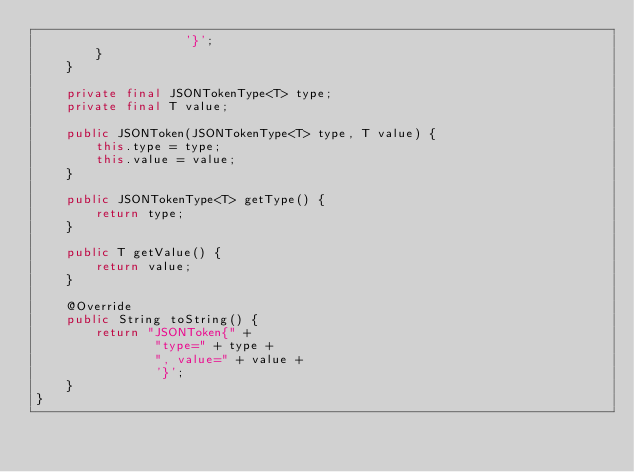Convert code to text. <code><loc_0><loc_0><loc_500><loc_500><_Java_>                    '}';
        }
    }

    private final JSONTokenType<T> type;
    private final T value;

    public JSONToken(JSONTokenType<T> type, T value) {
        this.type = type;
        this.value = value;
    }

    public JSONTokenType<T> getType() {
        return type;
    }

    public T getValue() {
        return value;
    }

    @Override
    public String toString() {
        return "JSONToken{" +
                "type=" + type +
                ", value=" + value +
                '}';
    }
}</code> 